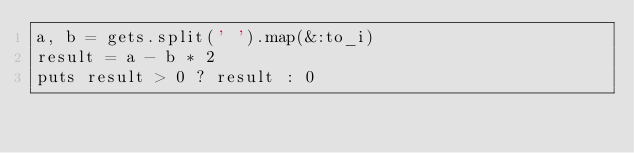<code> <loc_0><loc_0><loc_500><loc_500><_Ruby_>a, b = gets.split(' ').map(&:to_i)
result = a - b * 2
puts result > 0 ? result : 0</code> 